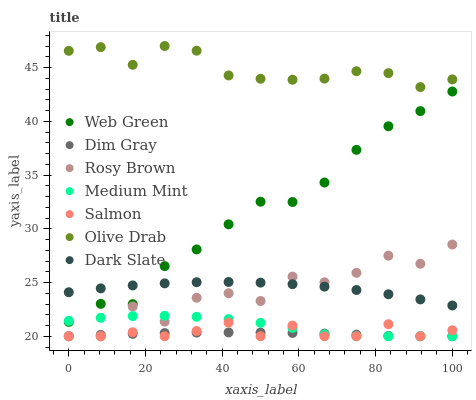Does Dim Gray have the minimum area under the curve?
Answer yes or no. Yes. Does Olive Drab have the maximum area under the curve?
Answer yes or no. Yes. Does Rosy Brown have the minimum area under the curve?
Answer yes or no. No. Does Rosy Brown have the maximum area under the curve?
Answer yes or no. No. Is Dim Gray the smoothest?
Answer yes or no. Yes. Is Rosy Brown the roughest?
Answer yes or no. Yes. Is Rosy Brown the smoothest?
Answer yes or no. No. Is Dim Gray the roughest?
Answer yes or no. No. Does Medium Mint have the lowest value?
Answer yes or no. Yes. Does Web Green have the lowest value?
Answer yes or no. No. Does Olive Drab have the highest value?
Answer yes or no. Yes. Does Rosy Brown have the highest value?
Answer yes or no. No. Is Dark Slate less than Olive Drab?
Answer yes or no. Yes. Is Olive Drab greater than Dim Gray?
Answer yes or no. Yes. Does Dim Gray intersect Salmon?
Answer yes or no. Yes. Is Dim Gray less than Salmon?
Answer yes or no. No. Is Dim Gray greater than Salmon?
Answer yes or no. No. Does Dark Slate intersect Olive Drab?
Answer yes or no. No. 